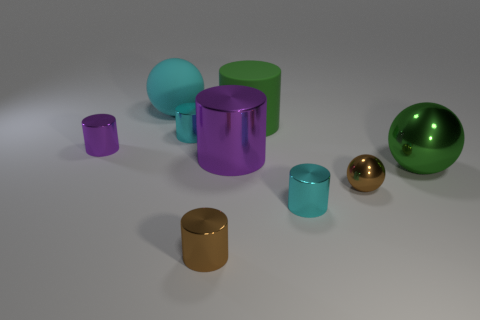Subtract all large metallic cylinders. How many cylinders are left? 5 Subtract all green cylinders. How many cylinders are left? 5 Subtract all brown cylinders. Subtract all red spheres. How many cylinders are left? 5 Subtract all cylinders. How many objects are left? 3 Subtract 0 gray balls. How many objects are left? 9 Subtract all big green metallic things. Subtract all tiny metal cylinders. How many objects are left? 4 Add 2 brown shiny objects. How many brown shiny objects are left? 4 Add 7 tiny brown cylinders. How many tiny brown cylinders exist? 8 